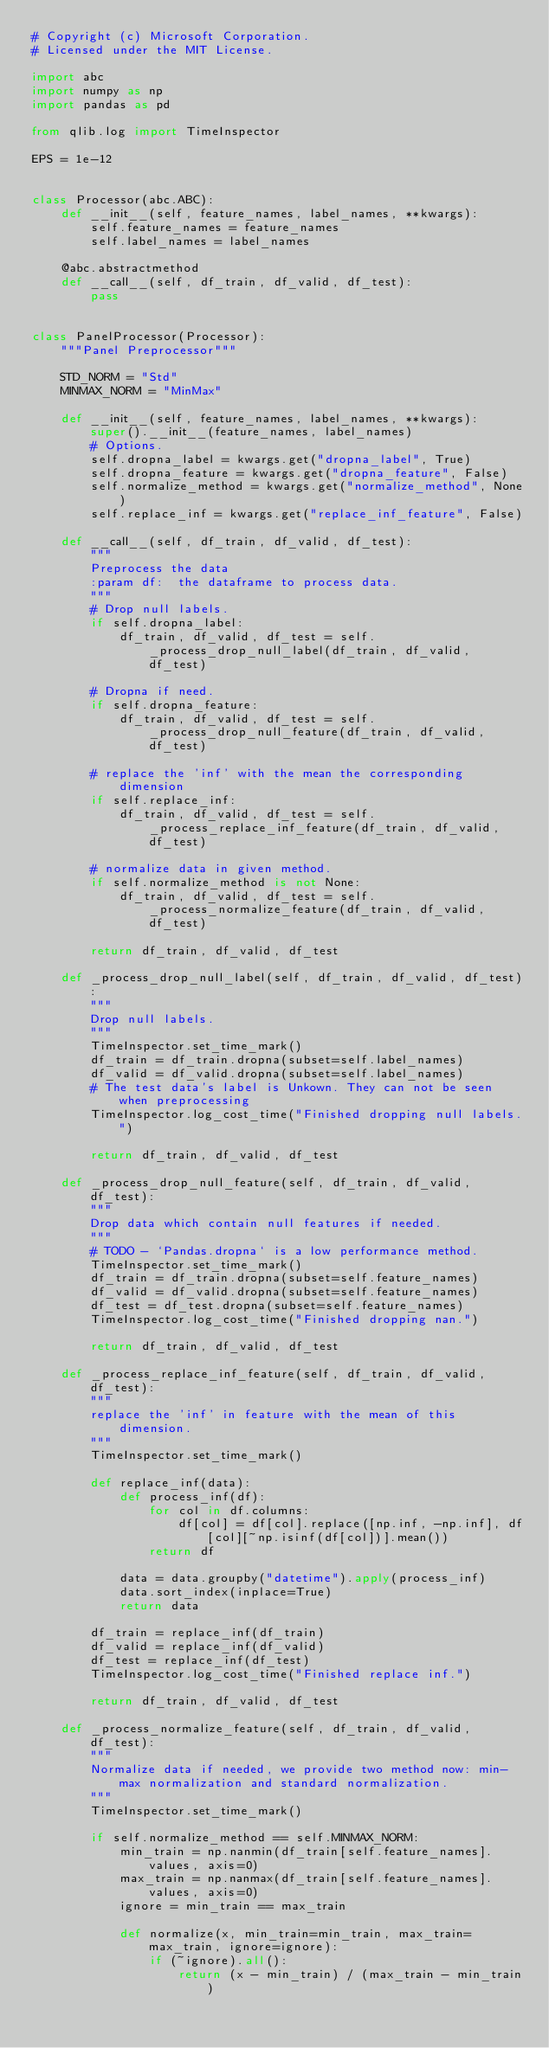Convert code to text. <code><loc_0><loc_0><loc_500><loc_500><_Python_># Copyright (c) Microsoft Corporation.
# Licensed under the MIT License.

import abc
import numpy as np
import pandas as pd

from qlib.log import TimeInspector

EPS = 1e-12


class Processor(abc.ABC):
    def __init__(self, feature_names, label_names, **kwargs):
        self.feature_names = feature_names
        self.label_names = label_names

    @abc.abstractmethod
    def __call__(self, df_train, df_valid, df_test):
        pass


class PanelProcessor(Processor):
    """Panel Preprocessor"""

    STD_NORM = "Std"
    MINMAX_NORM = "MinMax"

    def __init__(self, feature_names, label_names, **kwargs):
        super().__init__(feature_names, label_names)
        # Options.
        self.dropna_label = kwargs.get("dropna_label", True)
        self.dropna_feature = kwargs.get("dropna_feature", False)
        self.normalize_method = kwargs.get("normalize_method", None)
        self.replace_inf = kwargs.get("replace_inf_feature", False)

    def __call__(self, df_train, df_valid, df_test):
        """
        Preprocess the data
        :param df:  the dataframe to process data.
        """
        # Drop null labels.
        if self.dropna_label:
            df_train, df_valid, df_test = self._process_drop_null_label(df_train, df_valid, df_test)

        # Dropna if need.
        if self.dropna_feature:
            df_train, df_valid, df_test = self._process_drop_null_feature(df_train, df_valid, df_test)

        # replace the 'inf' with the mean the corresponding dimension
        if self.replace_inf:
            df_train, df_valid, df_test = self._process_replace_inf_feature(df_train, df_valid, df_test)

        # normalize data in given method.
        if self.normalize_method is not None:
            df_train, df_valid, df_test = self._process_normalize_feature(df_train, df_valid, df_test)

        return df_train, df_valid, df_test

    def _process_drop_null_label(self, df_train, df_valid, df_test):
        """
        Drop null labels.
        """
        TimeInspector.set_time_mark()
        df_train = df_train.dropna(subset=self.label_names)
        df_valid = df_valid.dropna(subset=self.label_names)
        # The test data's label is Unkown. They can not be seen when preprocessing
        TimeInspector.log_cost_time("Finished dropping null labels.")

        return df_train, df_valid, df_test

    def _process_drop_null_feature(self, df_train, df_valid, df_test):
        """
        Drop data which contain null features if needed.
        """
        # TODO - `Pandas.dropna` is a low performance method.
        TimeInspector.set_time_mark()
        df_train = df_train.dropna(subset=self.feature_names)
        df_valid = df_valid.dropna(subset=self.feature_names)
        df_test = df_test.dropna(subset=self.feature_names)
        TimeInspector.log_cost_time("Finished dropping nan.")

        return df_train, df_valid, df_test

    def _process_replace_inf_feature(self, df_train, df_valid, df_test):
        """
        replace the 'inf' in feature with the mean of this dimension.
        """
        TimeInspector.set_time_mark()

        def replace_inf(data):
            def process_inf(df):
                for col in df.columns:
                    df[col] = df[col].replace([np.inf, -np.inf], df[col][~np.isinf(df[col])].mean())
                return df

            data = data.groupby("datetime").apply(process_inf)
            data.sort_index(inplace=True)
            return data

        df_train = replace_inf(df_train)
        df_valid = replace_inf(df_valid)
        df_test = replace_inf(df_test)
        TimeInspector.log_cost_time("Finished replace inf.")

        return df_train, df_valid, df_test

    def _process_normalize_feature(self, df_train, df_valid, df_test):
        """
        Normalize data if needed, we provide two method now: min-max normalization and standard normalization.
        """
        TimeInspector.set_time_mark()

        if self.normalize_method == self.MINMAX_NORM:
            min_train = np.nanmin(df_train[self.feature_names].values, axis=0)
            max_train = np.nanmax(df_train[self.feature_names].values, axis=0)
            ignore = min_train == max_train

            def normalize(x, min_train=min_train, max_train=max_train, ignore=ignore):
                if (~ignore).all():
                    return (x - min_train) / (max_train - min_train)</code> 